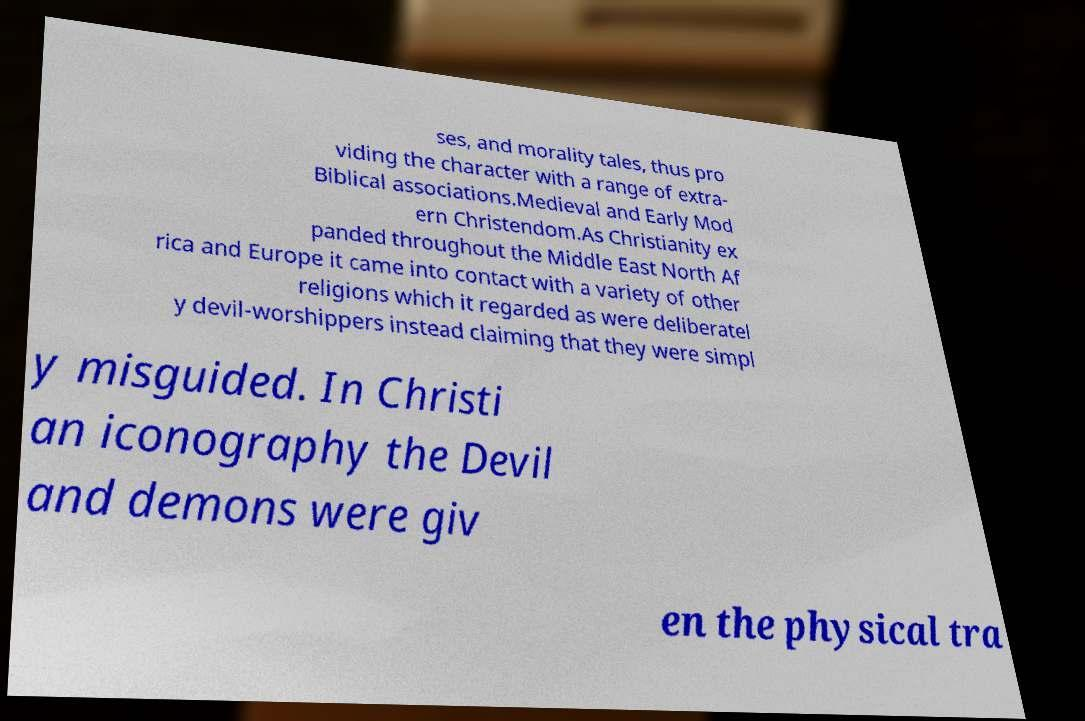Please identify and transcribe the text found in this image. ses, and morality tales, thus pro viding the character with a range of extra- Biblical associations.Medieval and Early Mod ern Christendom.As Christianity ex panded throughout the Middle East North Af rica and Europe it came into contact with a variety of other religions which it regarded as were deliberatel y devil-worshippers instead claiming that they were simpl y misguided. In Christi an iconography the Devil and demons were giv en the physical tra 